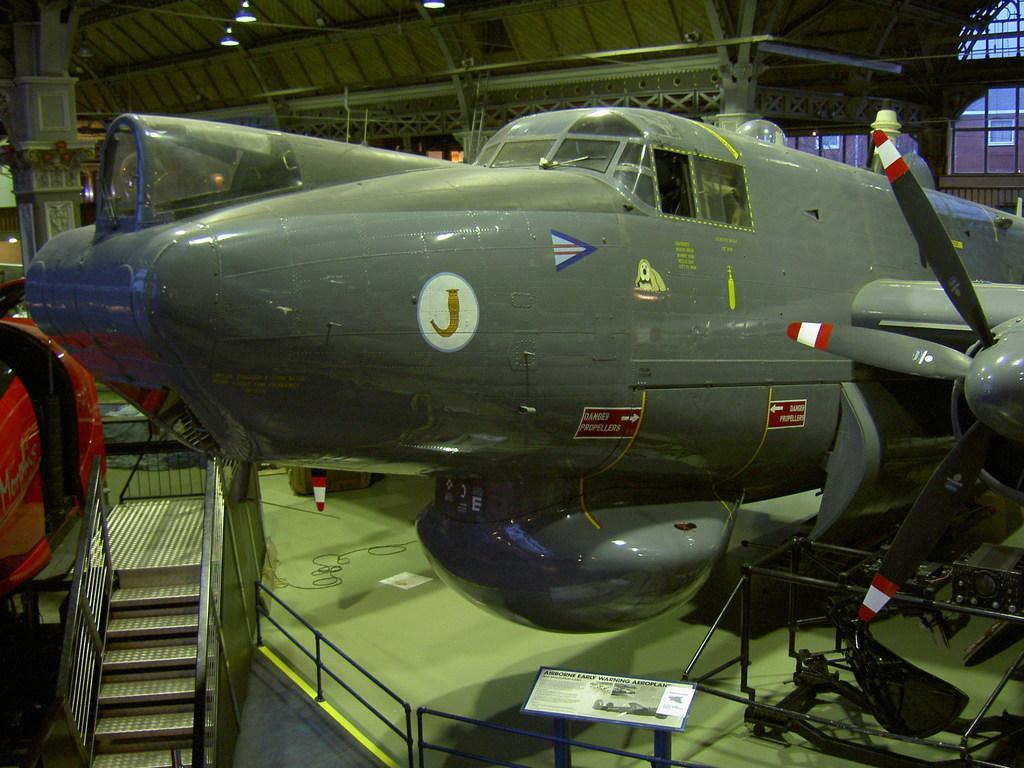Can you describe this image briefly? In this image we can see a aeroplane. There are staircase. There is a board with some text. At the top of the image there is ceiling with rods. There is a pillar. 